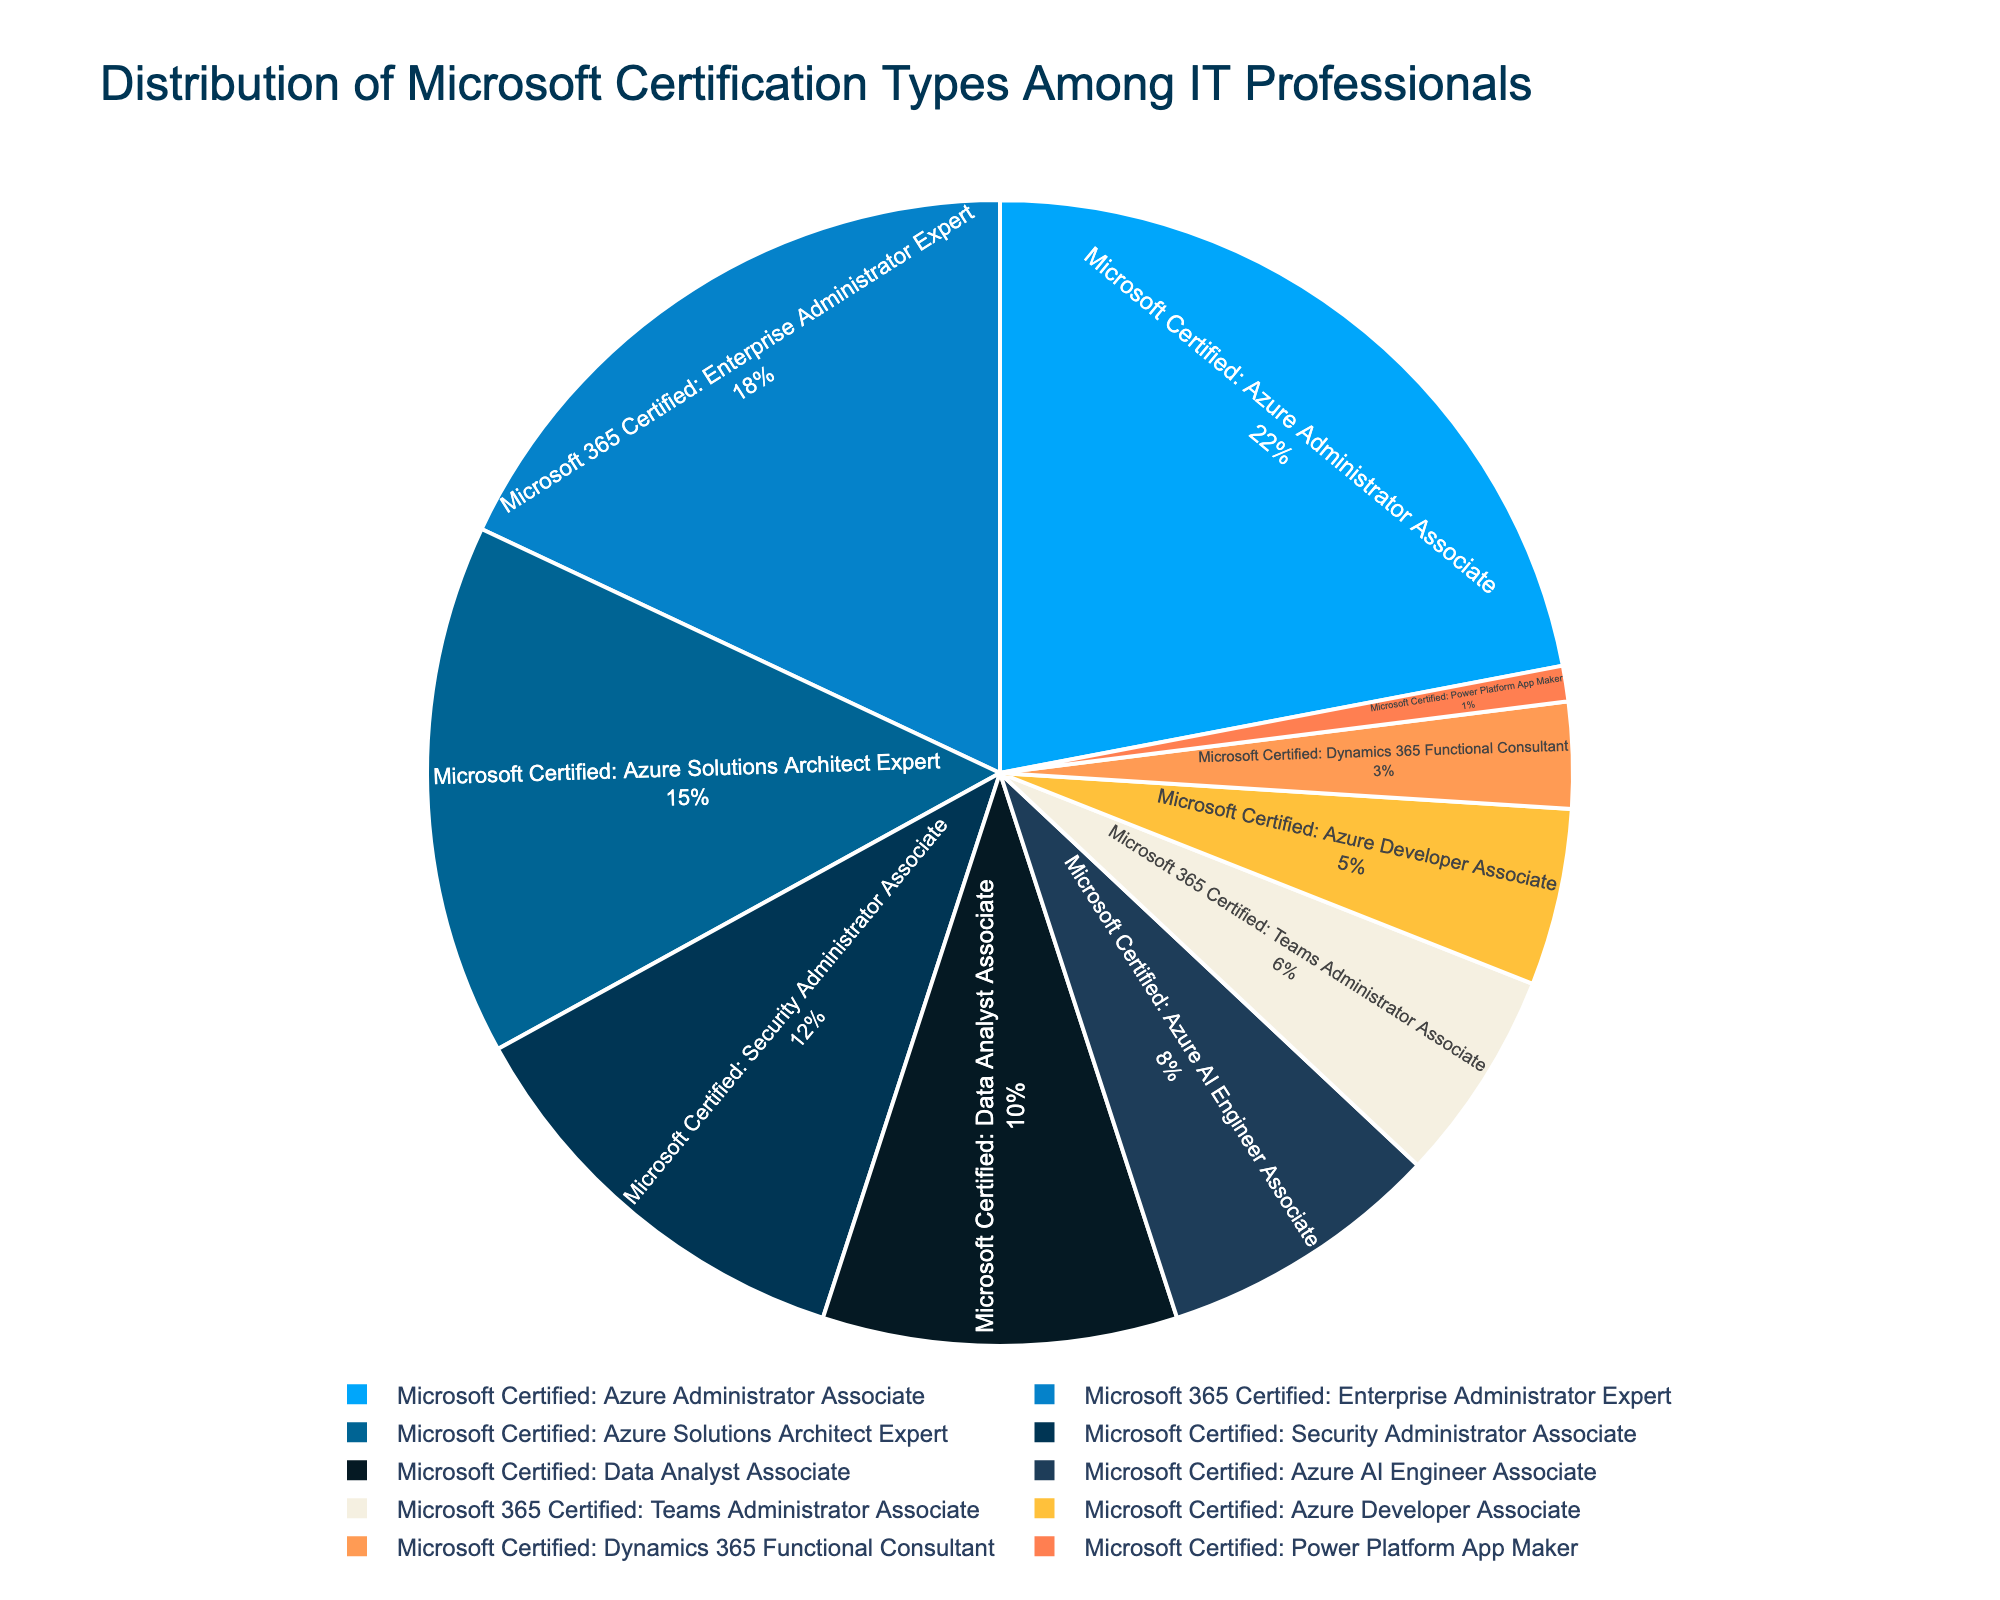What's the most common Microsoft certification type among IT professionals? The figure shows a pie chart with different segments representing the certification types and their percentages. The largest segment corresponds to the "Microsoft Certified: Azure Administrator Associate" at 22%.
Answer: Microsoft Certified: Azure Administrator Associate What's the combined percentage of "Microsoft Certified: Azure Solutions Architect Expert" and "Microsoft Certified: Azure AI Engineer Associate"? The "Microsoft Certified: Azure Solutions Architect Expert" has 15%, and the "Microsoft Certified: Azure AI Engineer Associate" has 8%. Adding them together is 15% + 8% = 23%.
Answer: 23% Which certification type has the smallest percentage? The smallest segment in the pie chart is labeled "Microsoft Certified: Power Platform App Maker," which has 1%.
Answer: Microsoft Certified: Power Platform App Maker How much more popular is the "Microsoft 365 Certified: Enterprise Administrator Expert" than the "Microsoft Certified: Dynamics 365 Functional Consultant"? "Microsoft 365 Certified: Enterprise Administrator Expert" has 18%, and "Microsoft Certified: Dynamics 365 Functional Consultant" has 3%. The difference is 18% - 3% = 15%.
Answer: 15% What is the percentage of certifications related to Azure (Azure Administrator Associate, Azure Solutions Architect Expert, Azure Security Engineer Associate, Azure AI Engineer Associate, Azure Developer Associate)? Adding the percentages: 22% (Azure Administrator Associate) + 15% (Azure Solutions Architect Expert) + 12% (Azure Security Engineer Associate) + 8% (Azure AI Engineer Associate) + 5% (Azure Developer Associate) = 62%.
Answer: 62% Which color represents the "Microsoft Certified: Data Analyst Associate" certification? The pie chart uses distinct colors for each certification type. "Microsoft Certified: Data Analyst Associate" corresponds to a segment colored in dark blue.
Answer: dark blue Is the "Microsoft 365 Certified: Teams Administrator Associate" more popular than the "Microsoft Certified: Azure Developer Associate"? The "Microsoft 365 Certified: Teams Administrator Associate" is at 6%, while the "Microsoft Certified: Azure Developer Associate" is at 5%. Since 6% is greater than 5%, the Teams Administrator is more popular.
Answer: Yes What is the average percentage of the top three certification types? The top three certification types are "Azure Administrator Associate" (22%), "Enterprise Administrator Expert" (18%), and "Azure Solutions Architect Expert" (15%). The average is (22% + 18% + 15%) / 3 = 55% / 3 ≈ 18.33%.
Answer: 18.33% How many certification types have a percentage greater than or equal to 10%? From the pie chart, the certification types with percentages greater than or equal to 10% are: Azure Administrator Associate (22%), Enterprise Administrator Expert (18%), Azure Solutions Architect Expert (15%), and Security Administrator Associate (12%), Data Analyst Associate (10%). That's a total of 5 certification types.
Answer: 5 